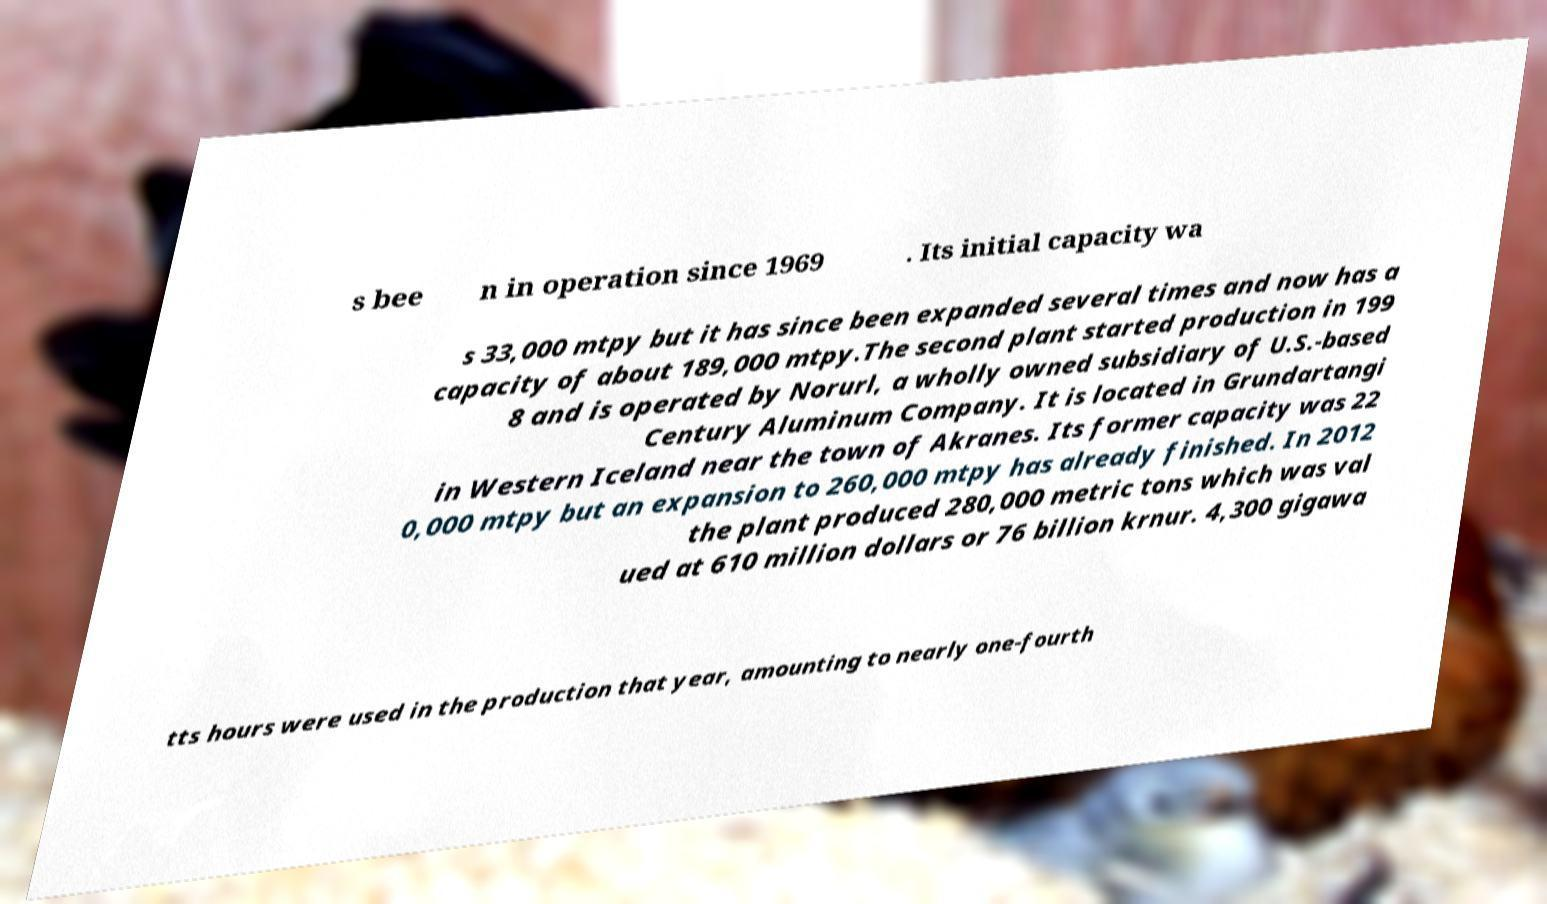What messages or text are displayed in this image? I need them in a readable, typed format. s bee n in operation since 1969 . Its initial capacity wa s 33,000 mtpy but it has since been expanded several times and now has a capacity of about 189,000 mtpy.The second plant started production in 199 8 and is operated by Norurl, a wholly owned subsidiary of U.S.-based Century Aluminum Company. It is located in Grundartangi in Western Iceland near the town of Akranes. Its former capacity was 22 0,000 mtpy but an expansion to 260,000 mtpy has already finished. In 2012 the plant produced 280,000 metric tons which was val ued at 610 million dollars or 76 billion krnur. 4,300 gigawa tts hours were used in the production that year, amounting to nearly one-fourth 